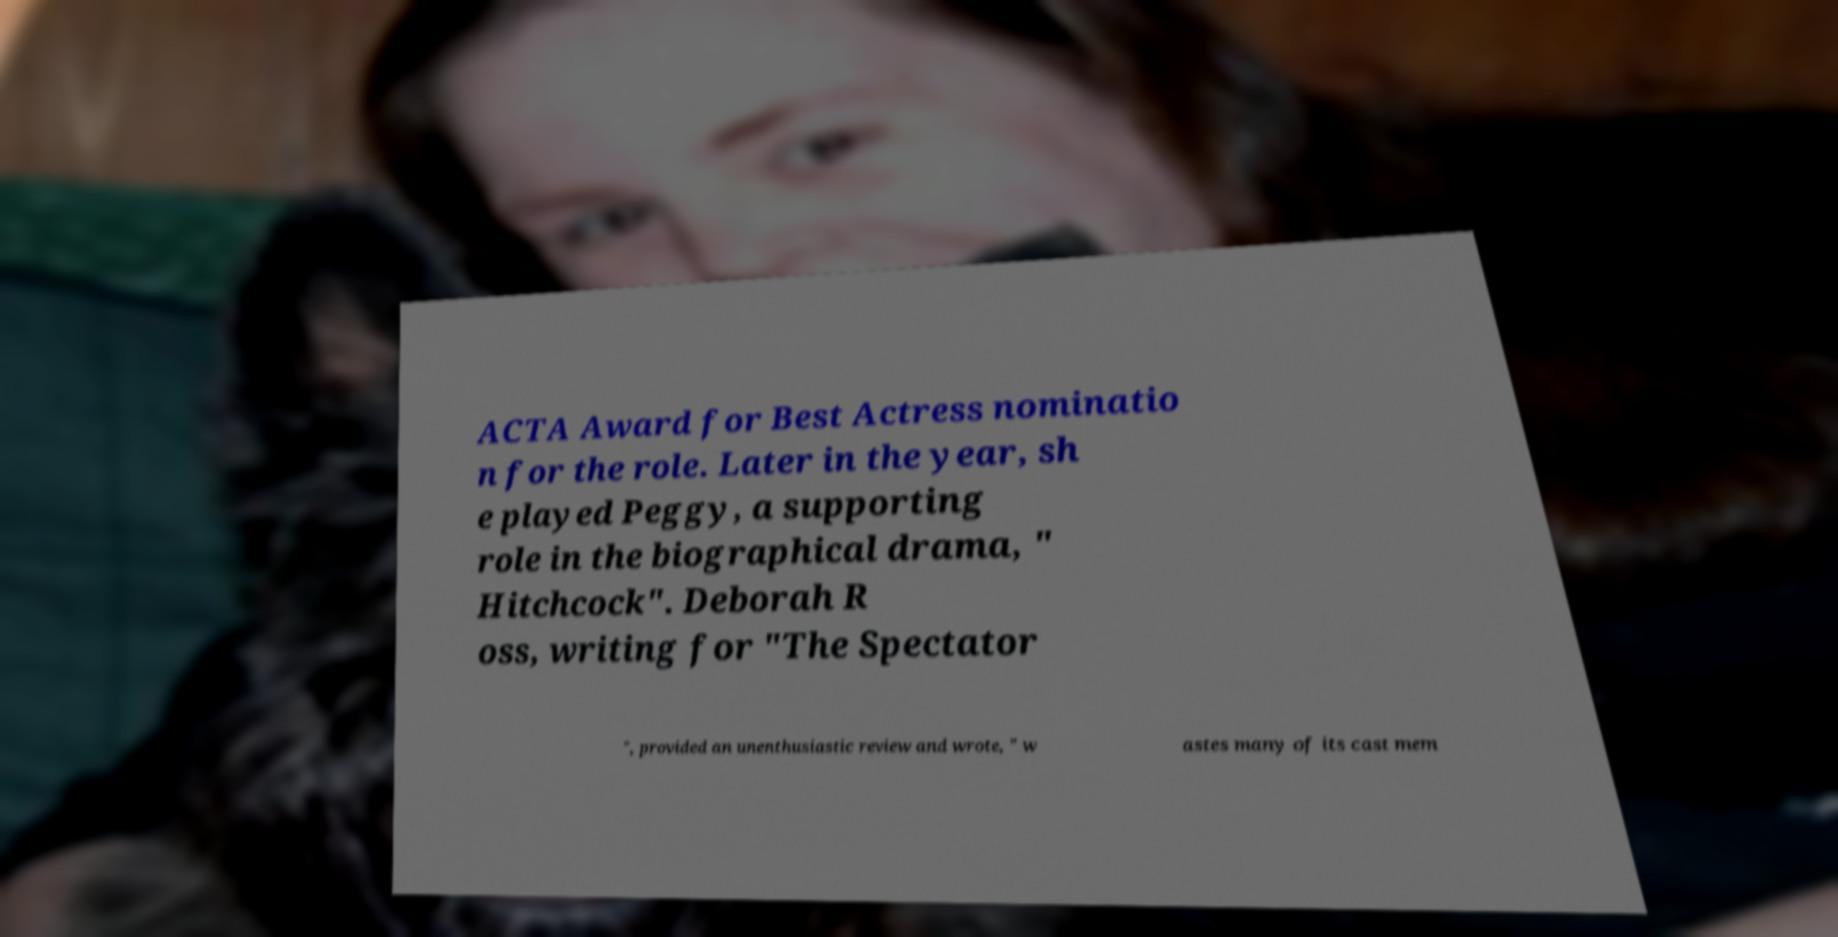Could you assist in decoding the text presented in this image and type it out clearly? ACTA Award for Best Actress nominatio n for the role. Later in the year, sh e played Peggy, a supporting role in the biographical drama, " Hitchcock". Deborah R oss, writing for "The Spectator ", provided an unenthusiastic review and wrote, " w astes many of its cast mem 